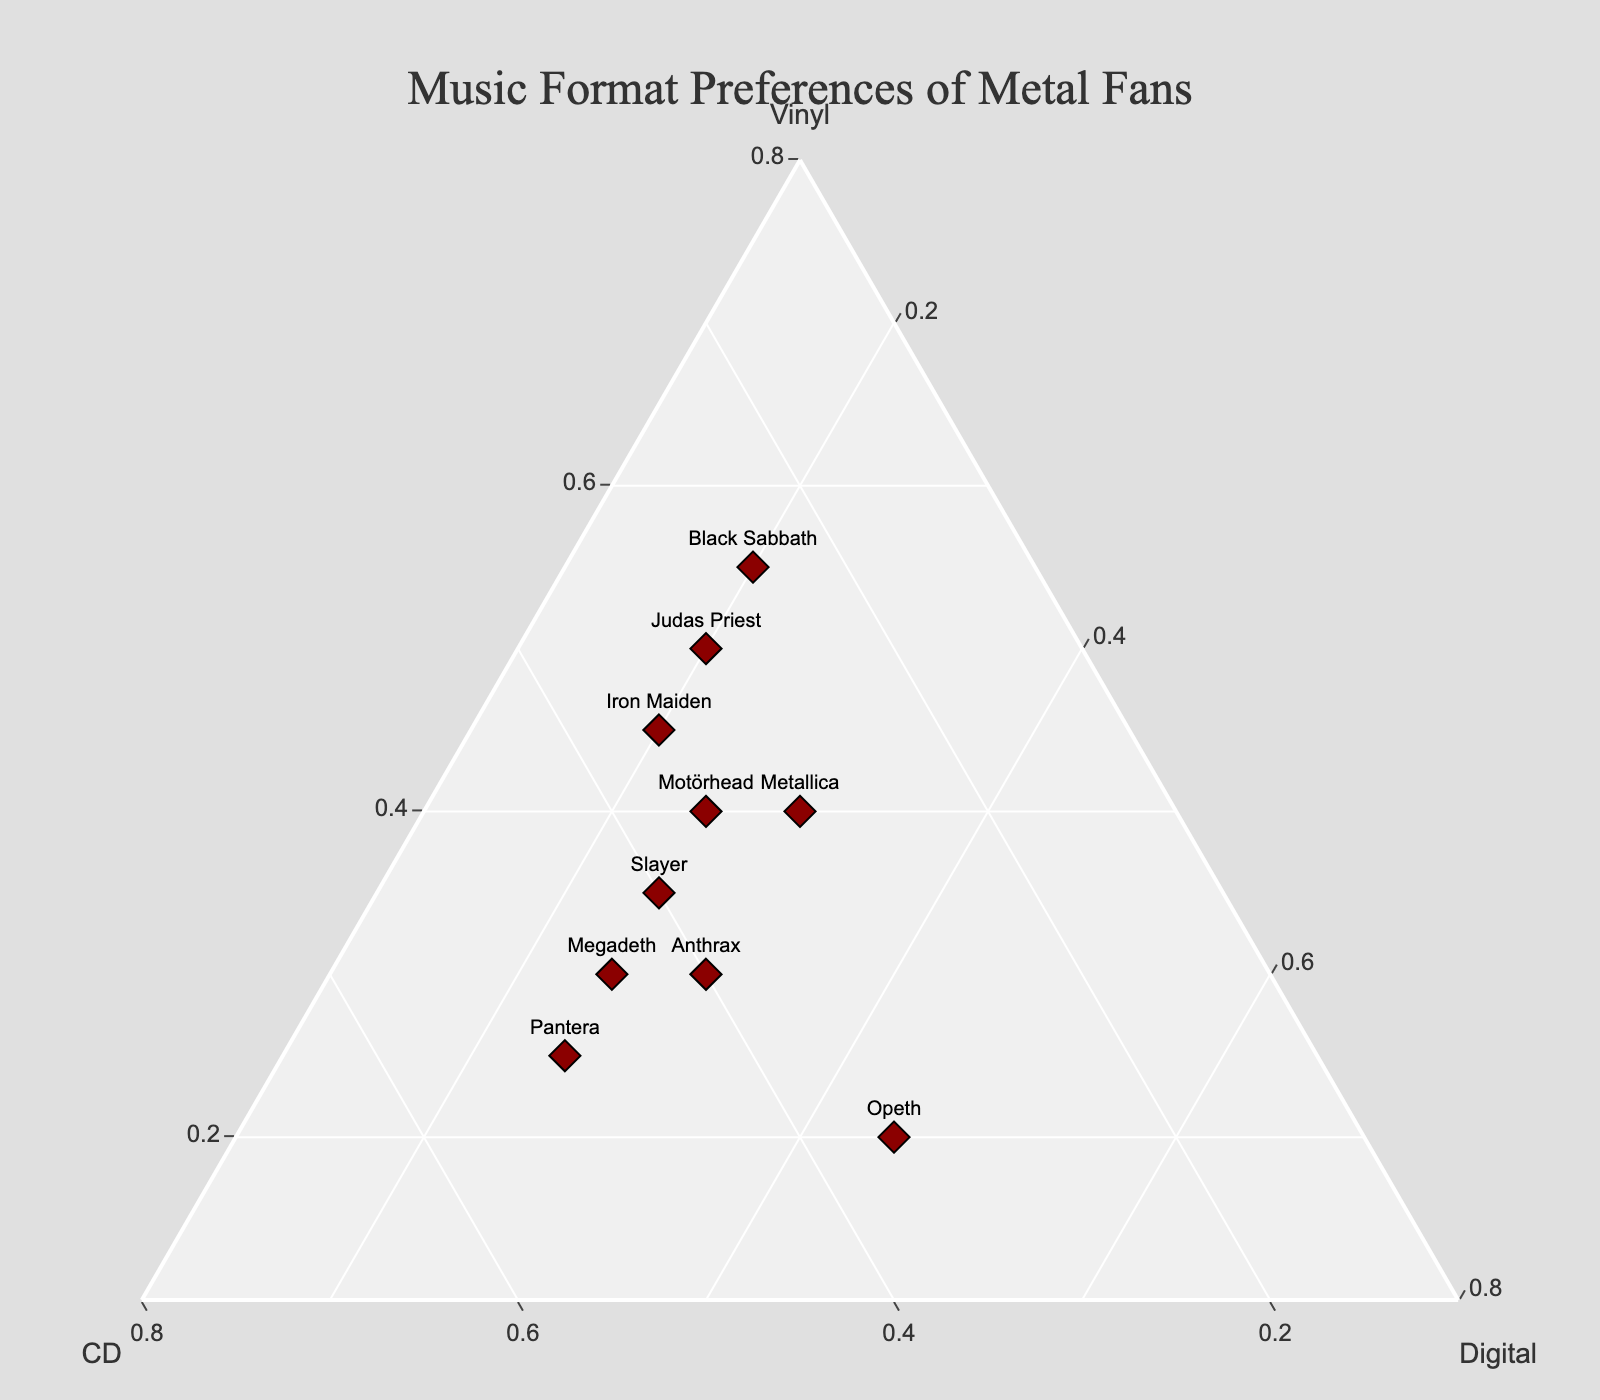what's the title of the plot? The title of the plot is often displayed prominently at the top and describes the content of the plot. In this case, it's "Music Format Preferences of Metal Fans," indicating the subject of the figure.
Answer: Music Format Preferences of Metal Fans which band has the highest preference for vinyl? Looking at the plot, the band with the highest position along the Vinyl axis has the highest preference for vinyl. In this case, Black Sabbath is positioned furthest along the Vinyl axis.
Answer: Black Sabbath which bands have equal preference for digital music? By finding bands that lie on the same level along the Digital axis, we see that Iron Maiden, Black Sabbath, and Judas Priest each have a digital preference of 20%, while Slayer and Megadeth both have 25%.
Answer: Iron Maiden, Black Sabbath, Judas Priest; Slayer, Megadeth what is the average preference for digital among all bands? Add up the digital preference percentages of all bands (20 + 30 + 20 + 25 + 25 + 20 + 25 + 25 + 30 + 45 = 265) and divide by the number of bands (10).
Answer: 26.5% which band has the most balanced preference for all three formats? A band with a balanced preference will be closer to the center of the ternary plot. Metallica has a fairly balanced preference with 40% Vinyl, 30% CD, and 30% Digital.
Answer: Metallica compare Pantera and Opeth: which one has a higher preference for CDs? By checking the positions along the CD axis, we find Pantera has a preference of 50% for CDs, while Opeth has 35%. Therefore, Pantera has a higher preference.
Answer: Pantera are there any bands that have a higher preference for digital than any other format? By checking the positions along the Digital axis, Opeth, with 45% for digital, has a higher preference for digital compared to vinyl and CD.
Answer: Opeth which band has the lowest preference for vinyl? The band lowest along the Vinyl axis has the lowest preference for vinyl, which is Opeth with 20%.
Answer: Opeth what is the median preference for CDs among the bands? Arranging the CD percentages in ascending order: [25, 25, 30, 30, 30, 35, 35, 40, 40, 45]. The median of 10 values is the average of the 5th and 6th values, which are both 35%.
Answer: 35% compare Iron Maiden and Judas Priest: which has a higher preference for vinyl and by how much? Comparing their positions, Iron Maiden has a 45% preference for vinyl while Judas Priest has 50%. The difference is Judas Priest's 50% - Iron Maiden's 45% = 5%.
Answer: Judas Priest, 5% 